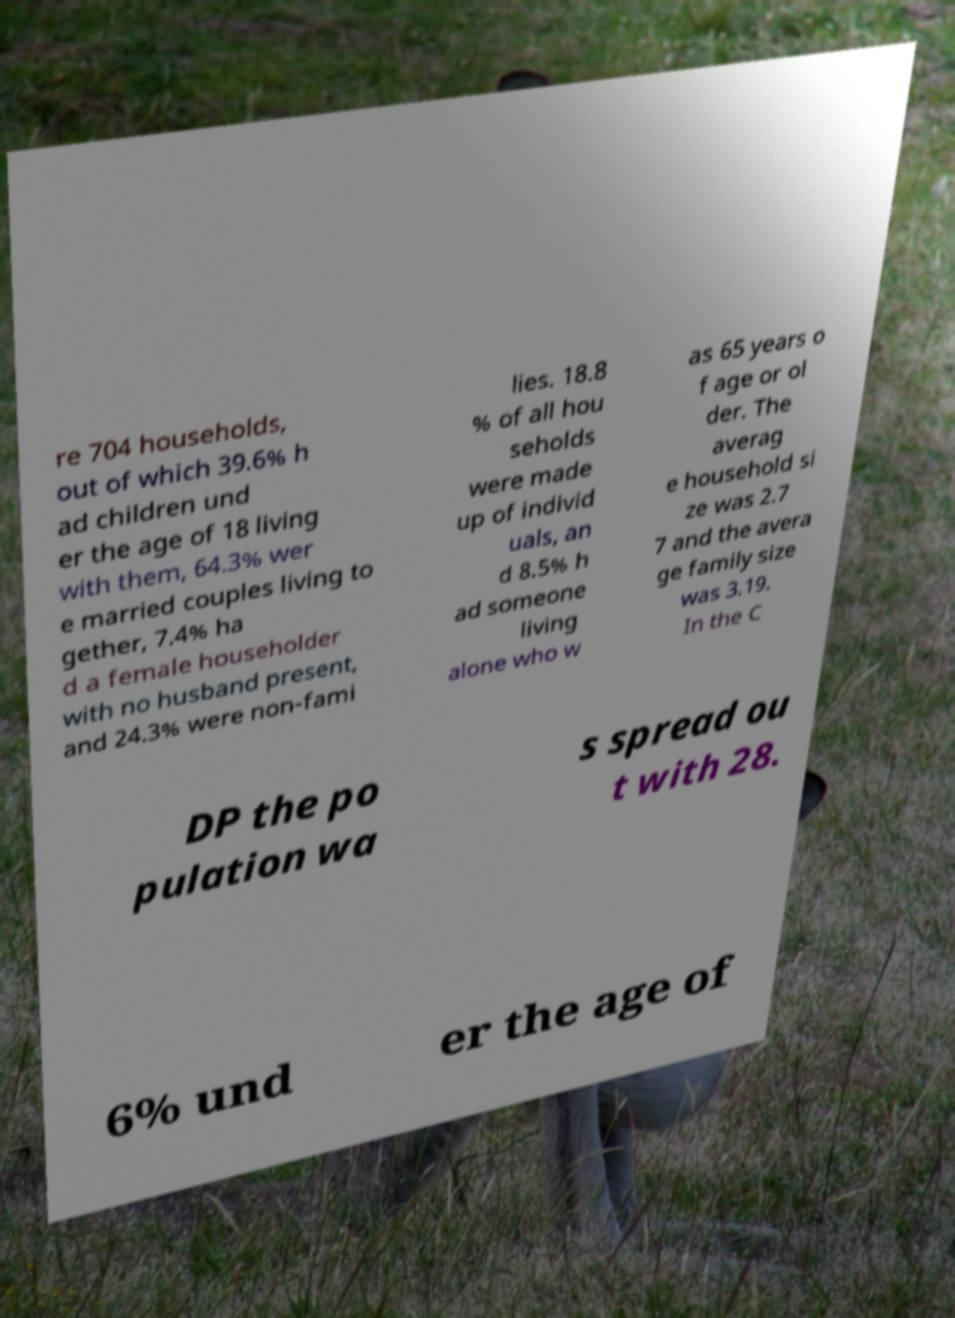Please read and relay the text visible in this image. What does it say? re 704 households, out of which 39.6% h ad children und er the age of 18 living with them, 64.3% wer e married couples living to gether, 7.4% ha d a female householder with no husband present, and 24.3% were non-fami lies. 18.8 % of all hou seholds were made up of individ uals, an d 8.5% h ad someone living alone who w as 65 years o f age or ol der. The averag e household si ze was 2.7 7 and the avera ge family size was 3.19. In the C DP the po pulation wa s spread ou t with 28. 6% und er the age of 